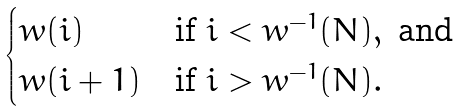<formula> <loc_0><loc_0><loc_500><loc_500>\begin{cases} w ( i ) & \text {if } i < w ^ { - 1 } ( N ) , \text { and } \\ w ( i + 1 ) & \text {if } i > w ^ { - 1 } ( N ) . \end{cases}</formula> 